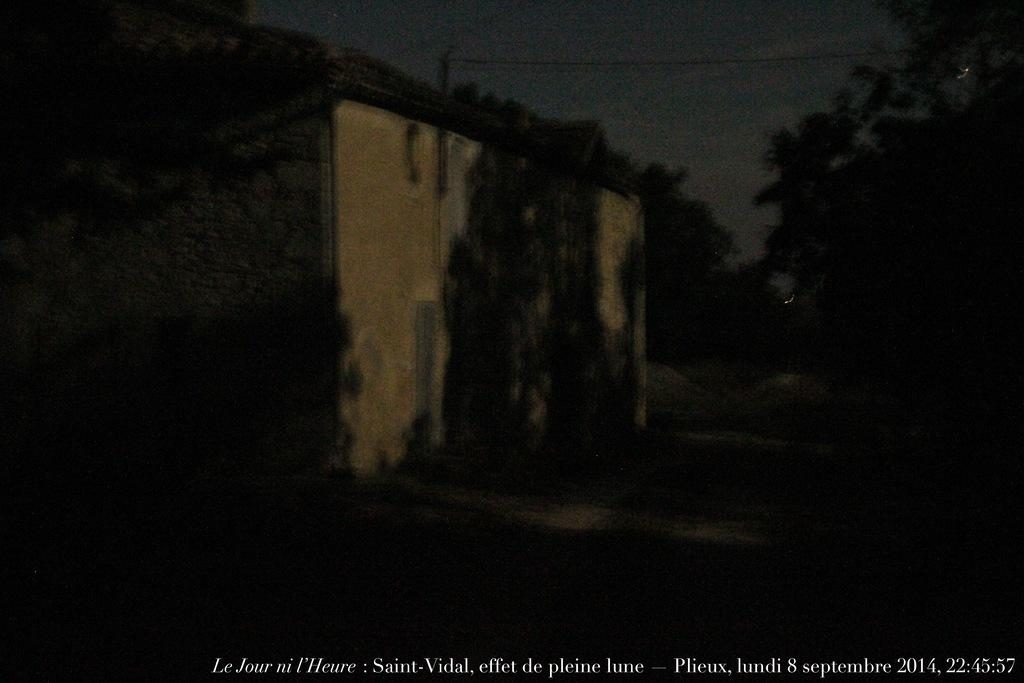What is located in the middle of the image? There is a wall in the middle of the image. What type of vegetation is on the right side of the image? There are trees on the right side of the image. What is visible at the top of the image? The sky is visible at the top of the image. What color is the name written at the bottom of the image? The name is written in white color at the bottom of the image. What type of mint can be seen growing on the wall in the image? There is no mint present in the image; it only features a wall, trees, sky, and a name written in white color. What color is the chalk used to write the name at the bottom of the image? There is no chalk mentioned in the image; the name is written in white color. 